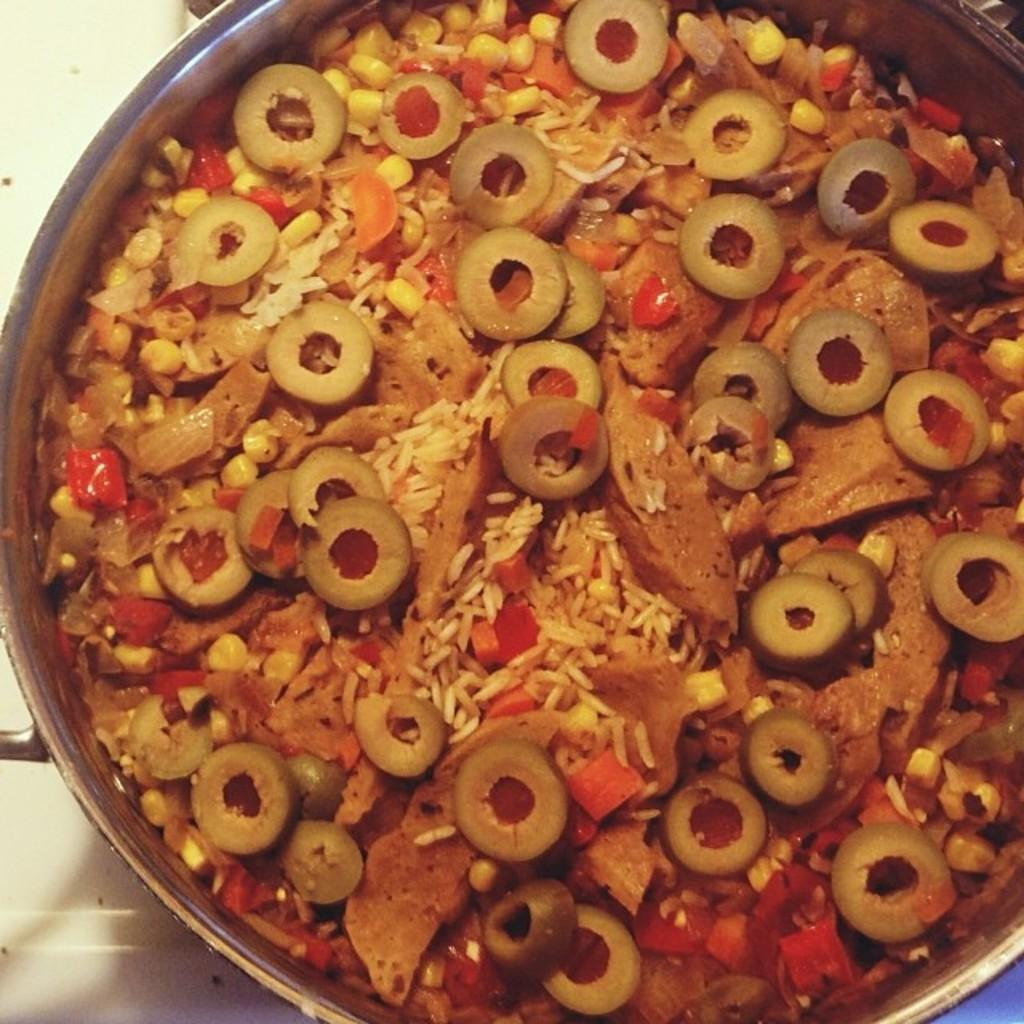What is present in the image? There is a container in the image. What is inside the container? There are food items in the container. What type of behavior do the dolls exhibit during the meeting in the image? There are no dolls or meetings present in the image. 